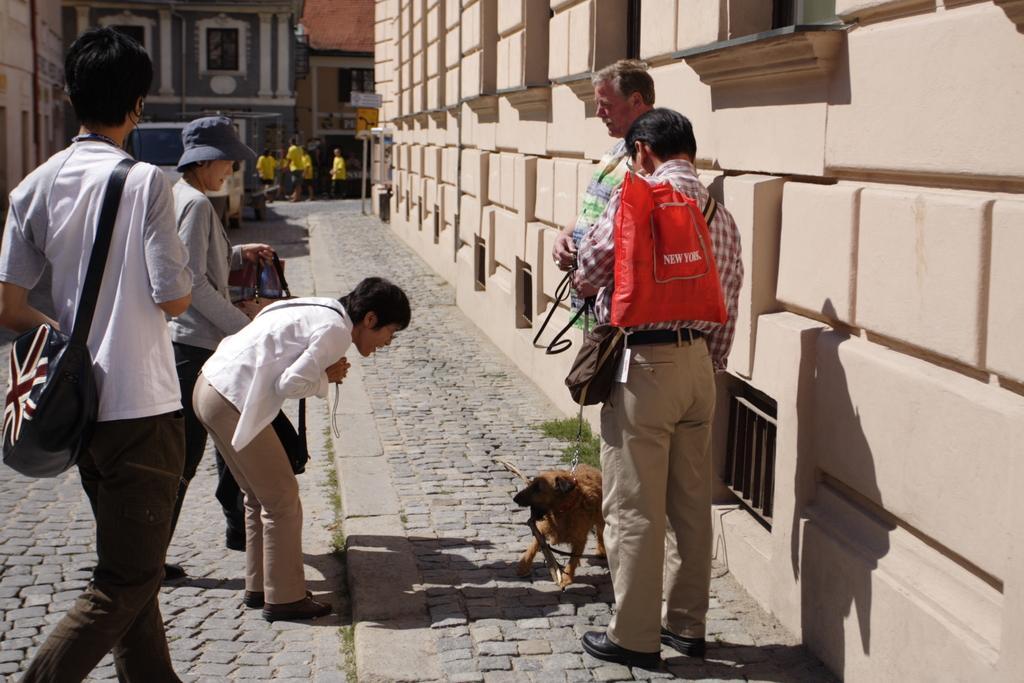Describe this image in one or two sentences. This is a picture taken in the outdoors. It is sunny. There are group of people standing on the floor. The person in white shirt is looking at a dog. The man in checks shirt was holding a red bag. Behind the people there are group of people in yellow shirt was standing on a road. Background of the people there are buildings. 